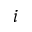<formula> <loc_0><loc_0><loc_500><loc_500>i</formula> 